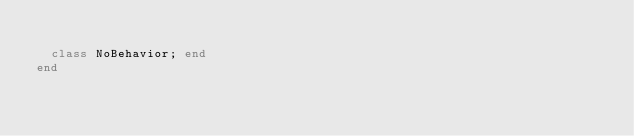<code> <loc_0><loc_0><loc_500><loc_500><_Ruby_>
  class NoBehavior; end
end
</code> 